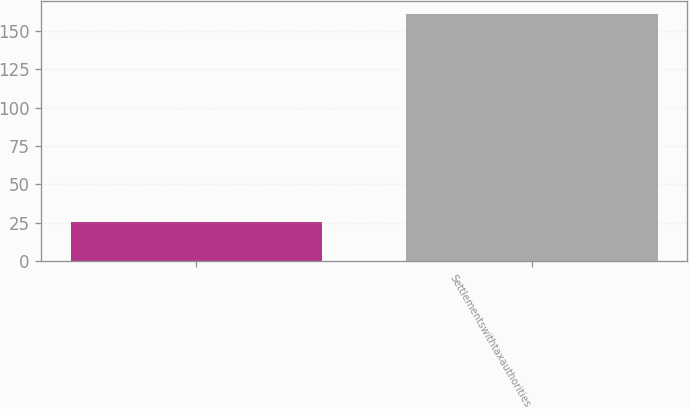Convert chart. <chart><loc_0><loc_0><loc_500><loc_500><bar_chart><ecel><fcel>Settlementswithtaxauthorities<nl><fcel>25.2<fcel>161.2<nl></chart> 